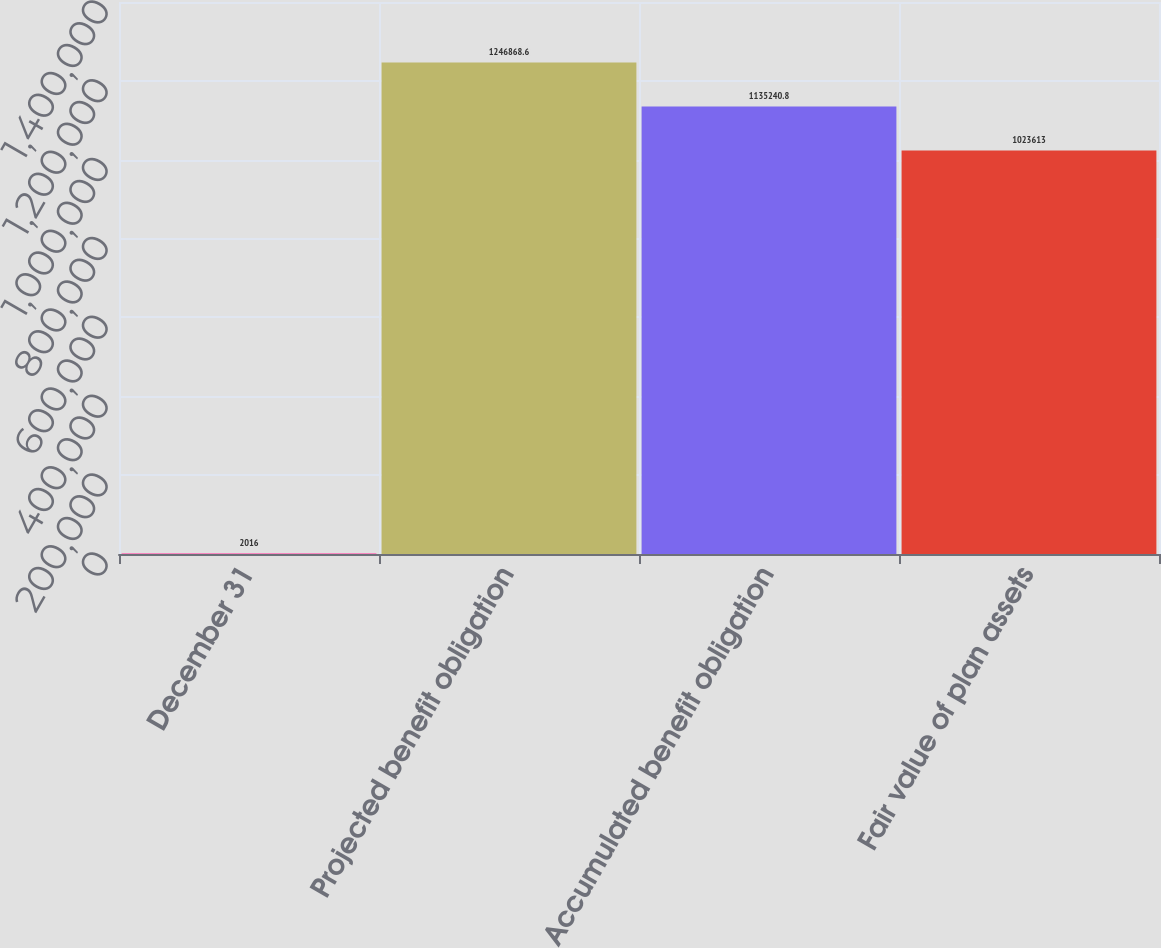<chart> <loc_0><loc_0><loc_500><loc_500><bar_chart><fcel>December 31<fcel>Projected benefit obligation<fcel>Accumulated benefit obligation<fcel>Fair value of plan assets<nl><fcel>2016<fcel>1.24687e+06<fcel>1.13524e+06<fcel>1.02361e+06<nl></chart> 